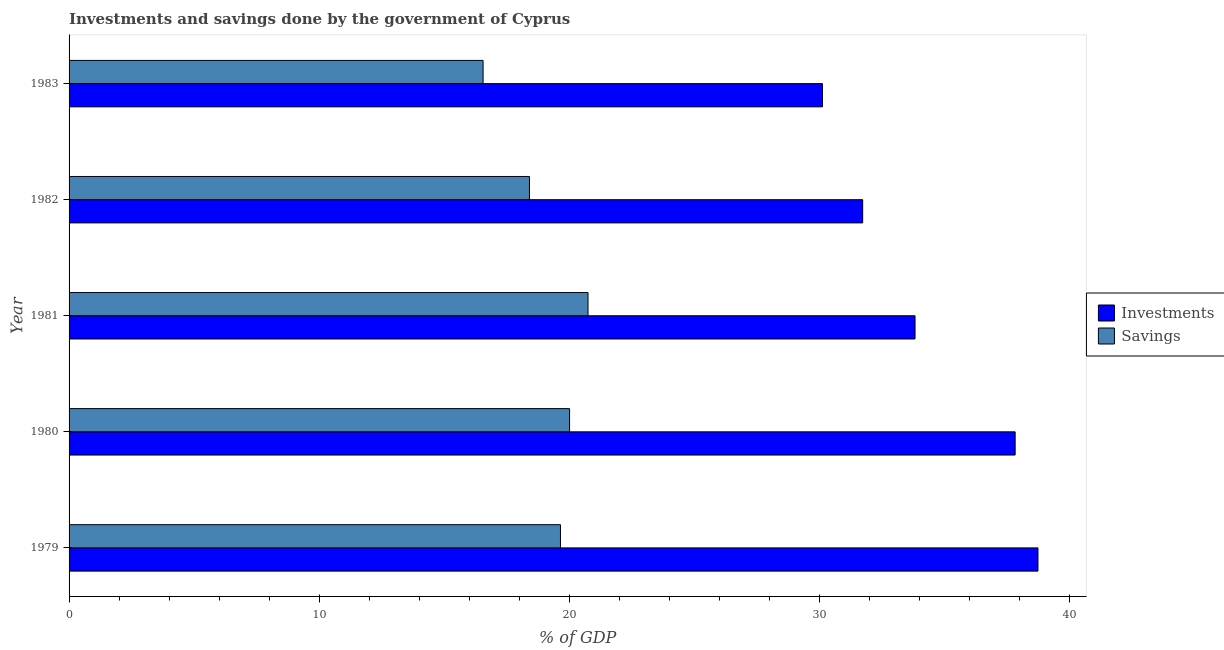How many different coloured bars are there?
Offer a very short reply. 2. How many groups of bars are there?
Ensure brevity in your answer.  5. How many bars are there on the 2nd tick from the top?
Your answer should be very brief. 2. In how many cases, is the number of bars for a given year not equal to the number of legend labels?
Your response must be concise. 0. What is the savings of government in 1982?
Ensure brevity in your answer.  18.4. Across all years, what is the maximum investments of government?
Offer a terse response. 38.73. Across all years, what is the minimum savings of government?
Ensure brevity in your answer.  16.55. In which year was the investments of government maximum?
Offer a terse response. 1979. What is the total savings of government in the graph?
Your answer should be very brief. 95.34. What is the difference between the savings of government in 1980 and that in 1982?
Your response must be concise. 1.6. What is the difference between the investments of government in 1980 and the savings of government in 1983?
Provide a short and direct response. 21.27. What is the average investments of government per year?
Provide a short and direct response. 34.44. In the year 1983, what is the difference between the investments of government and savings of government?
Offer a terse response. 13.57. Is the difference between the savings of government in 1980 and 1982 greater than the difference between the investments of government in 1980 and 1982?
Your answer should be very brief. No. What is the difference between the highest and the lowest savings of government?
Make the answer very short. 4.19. What does the 2nd bar from the top in 1983 represents?
Your response must be concise. Investments. What does the 1st bar from the bottom in 1983 represents?
Your answer should be compact. Investments. How many bars are there?
Give a very brief answer. 10. Does the graph contain any zero values?
Offer a terse response. No. Where does the legend appear in the graph?
Your answer should be compact. Center right. How many legend labels are there?
Keep it short and to the point. 2. How are the legend labels stacked?
Keep it short and to the point. Vertical. What is the title of the graph?
Your answer should be very brief. Investments and savings done by the government of Cyprus. Does "% of GNI" appear as one of the legend labels in the graph?
Keep it short and to the point. No. What is the label or title of the X-axis?
Provide a short and direct response. % of GDP. What is the label or title of the Y-axis?
Your answer should be very brief. Year. What is the % of GDP of Investments in 1979?
Your response must be concise. 38.73. What is the % of GDP in Savings in 1979?
Your response must be concise. 19.64. What is the % of GDP of Investments in 1980?
Ensure brevity in your answer.  37.81. What is the % of GDP of Savings in 1980?
Your response must be concise. 20.01. What is the % of GDP in Investments in 1981?
Make the answer very short. 33.81. What is the % of GDP in Savings in 1981?
Your answer should be very brief. 20.74. What is the % of GDP in Investments in 1982?
Your response must be concise. 31.72. What is the % of GDP in Savings in 1982?
Provide a succinct answer. 18.4. What is the % of GDP of Investments in 1983?
Provide a succinct answer. 30.11. What is the % of GDP of Savings in 1983?
Make the answer very short. 16.55. Across all years, what is the maximum % of GDP in Investments?
Your response must be concise. 38.73. Across all years, what is the maximum % of GDP of Savings?
Your answer should be very brief. 20.74. Across all years, what is the minimum % of GDP of Investments?
Offer a very short reply. 30.11. Across all years, what is the minimum % of GDP in Savings?
Your response must be concise. 16.55. What is the total % of GDP of Investments in the graph?
Your answer should be compact. 172.19. What is the total % of GDP in Savings in the graph?
Your answer should be very brief. 95.34. What is the difference between the % of GDP of Investments in 1979 and that in 1980?
Make the answer very short. 0.91. What is the difference between the % of GDP of Savings in 1979 and that in 1980?
Give a very brief answer. -0.36. What is the difference between the % of GDP of Investments in 1979 and that in 1981?
Offer a terse response. 4.91. What is the difference between the % of GDP of Savings in 1979 and that in 1981?
Provide a succinct answer. -1.1. What is the difference between the % of GDP of Investments in 1979 and that in 1982?
Provide a short and direct response. 7.01. What is the difference between the % of GDP of Savings in 1979 and that in 1982?
Offer a terse response. 1.24. What is the difference between the % of GDP in Investments in 1979 and that in 1983?
Offer a terse response. 8.61. What is the difference between the % of GDP of Savings in 1979 and that in 1983?
Offer a terse response. 3.09. What is the difference between the % of GDP in Investments in 1980 and that in 1981?
Give a very brief answer. 4. What is the difference between the % of GDP in Savings in 1980 and that in 1981?
Your response must be concise. -0.74. What is the difference between the % of GDP of Investments in 1980 and that in 1982?
Keep it short and to the point. 6.09. What is the difference between the % of GDP of Savings in 1980 and that in 1982?
Keep it short and to the point. 1.6. What is the difference between the % of GDP in Investments in 1980 and that in 1983?
Your answer should be compact. 7.7. What is the difference between the % of GDP of Savings in 1980 and that in 1983?
Your answer should be compact. 3.46. What is the difference between the % of GDP in Investments in 1981 and that in 1982?
Your answer should be very brief. 2.09. What is the difference between the % of GDP in Savings in 1981 and that in 1982?
Keep it short and to the point. 2.34. What is the difference between the % of GDP of Investments in 1981 and that in 1983?
Keep it short and to the point. 3.7. What is the difference between the % of GDP of Savings in 1981 and that in 1983?
Keep it short and to the point. 4.19. What is the difference between the % of GDP in Investments in 1982 and that in 1983?
Offer a very short reply. 1.61. What is the difference between the % of GDP in Savings in 1982 and that in 1983?
Make the answer very short. 1.85. What is the difference between the % of GDP in Investments in 1979 and the % of GDP in Savings in 1980?
Your answer should be very brief. 18.72. What is the difference between the % of GDP of Investments in 1979 and the % of GDP of Savings in 1981?
Offer a terse response. 17.98. What is the difference between the % of GDP of Investments in 1979 and the % of GDP of Savings in 1982?
Ensure brevity in your answer.  20.32. What is the difference between the % of GDP in Investments in 1979 and the % of GDP in Savings in 1983?
Provide a succinct answer. 22.18. What is the difference between the % of GDP of Investments in 1980 and the % of GDP of Savings in 1981?
Ensure brevity in your answer.  17.07. What is the difference between the % of GDP of Investments in 1980 and the % of GDP of Savings in 1982?
Provide a short and direct response. 19.41. What is the difference between the % of GDP of Investments in 1980 and the % of GDP of Savings in 1983?
Your answer should be compact. 21.27. What is the difference between the % of GDP in Investments in 1981 and the % of GDP in Savings in 1982?
Provide a succinct answer. 15.41. What is the difference between the % of GDP of Investments in 1981 and the % of GDP of Savings in 1983?
Provide a succinct answer. 17.26. What is the difference between the % of GDP of Investments in 1982 and the % of GDP of Savings in 1983?
Your answer should be compact. 15.17. What is the average % of GDP of Investments per year?
Ensure brevity in your answer.  34.44. What is the average % of GDP of Savings per year?
Your response must be concise. 19.07. In the year 1979, what is the difference between the % of GDP in Investments and % of GDP in Savings?
Your answer should be compact. 19.09. In the year 1980, what is the difference between the % of GDP of Investments and % of GDP of Savings?
Keep it short and to the point. 17.81. In the year 1981, what is the difference between the % of GDP of Investments and % of GDP of Savings?
Your answer should be compact. 13.07. In the year 1982, what is the difference between the % of GDP of Investments and % of GDP of Savings?
Provide a succinct answer. 13.32. In the year 1983, what is the difference between the % of GDP in Investments and % of GDP in Savings?
Offer a terse response. 13.57. What is the ratio of the % of GDP of Investments in 1979 to that in 1980?
Provide a succinct answer. 1.02. What is the ratio of the % of GDP in Savings in 1979 to that in 1980?
Keep it short and to the point. 0.98. What is the ratio of the % of GDP in Investments in 1979 to that in 1981?
Offer a very short reply. 1.15. What is the ratio of the % of GDP of Savings in 1979 to that in 1981?
Offer a very short reply. 0.95. What is the ratio of the % of GDP of Investments in 1979 to that in 1982?
Ensure brevity in your answer.  1.22. What is the ratio of the % of GDP of Savings in 1979 to that in 1982?
Offer a very short reply. 1.07. What is the ratio of the % of GDP of Investments in 1979 to that in 1983?
Offer a very short reply. 1.29. What is the ratio of the % of GDP of Savings in 1979 to that in 1983?
Provide a succinct answer. 1.19. What is the ratio of the % of GDP of Investments in 1980 to that in 1981?
Give a very brief answer. 1.12. What is the ratio of the % of GDP of Savings in 1980 to that in 1981?
Offer a very short reply. 0.96. What is the ratio of the % of GDP of Investments in 1980 to that in 1982?
Provide a short and direct response. 1.19. What is the ratio of the % of GDP of Savings in 1980 to that in 1982?
Keep it short and to the point. 1.09. What is the ratio of the % of GDP in Investments in 1980 to that in 1983?
Your answer should be compact. 1.26. What is the ratio of the % of GDP of Savings in 1980 to that in 1983?
Make the answer very short. 1.21. What is the ratio of the % of GDP in Investments in 1981 to that in 1982?
Your answer should be compact. 1.07. What is the ratio of the % of GDP in Savings in 1981 to that in 1982?
Keep it short and to the point. 1.13. What is the ratio of the % of GDP in Investments in 1981 to that in 1983?
Offer a very short reply. 1.12. What is the ratio of the % of GDP of Savings in 1981 to that in 1983?
Offer a terse response. 1.25. What is the ratio of the % of GDP of Investments in 1982 to that in 1983?
Make the answer very short. 1.05. What is the ratio of the % of GDP of Savings in 1982 to that in 1983?
Provide a short and direct response. 1.11. What is the difference between the highest and the second highest % of GDP of Investments?
Your answer should be compact. 0.91. What is the difference between the highest and the second highest % of GDP of Savings?
Your answer should be very brief. 0.74. What is the difference between the highest and the lowest % of GDP of Investments?
Keep it short and to the point. 8.61. What is the difference between the highest and the lowest % of GDP of Savings?
Your response must be concise. 4.19. 